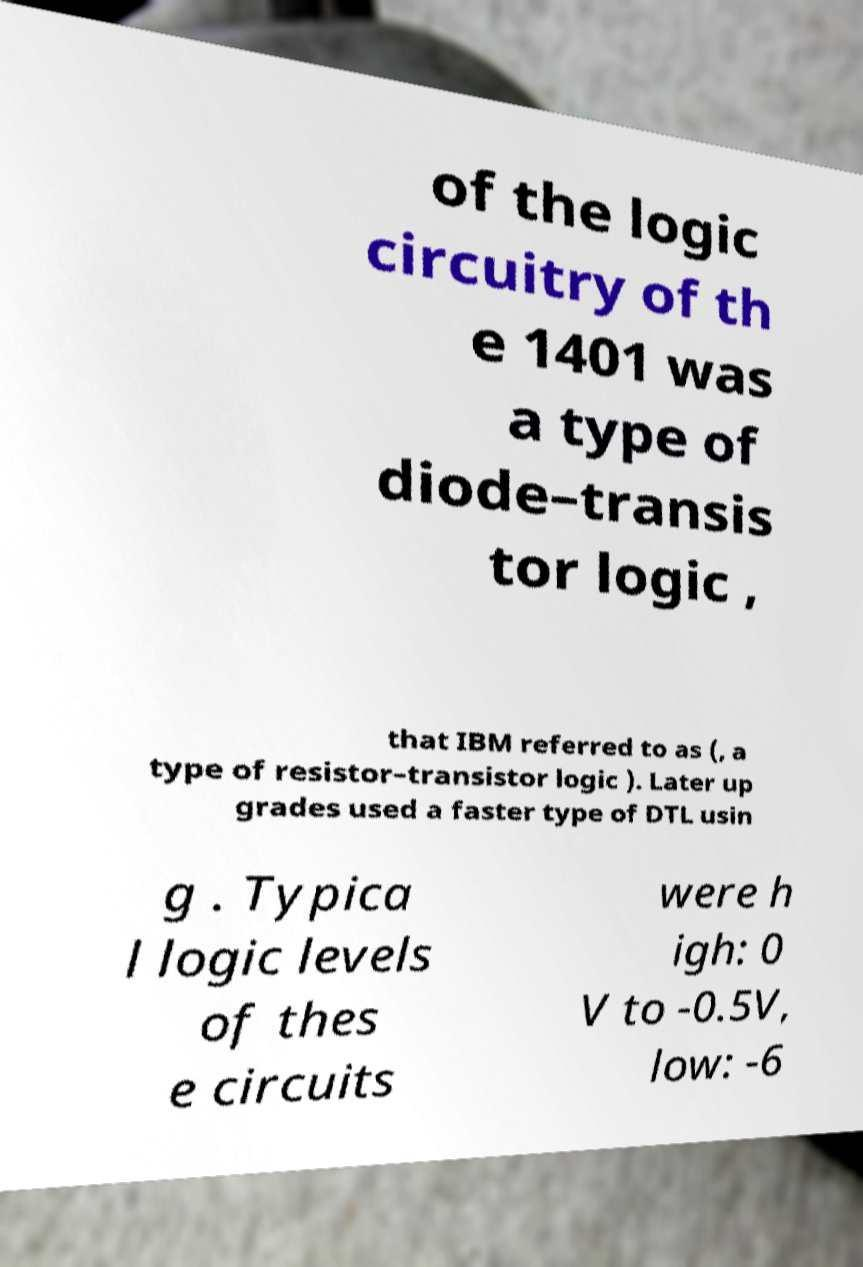Could you extract and type out the text from this image? of the logic circuitry of th e 1401 was a type of diode–transis tor logic , that IBM referred to as (, a type of resistor–transistor logic ). Later up grades used a faster type of DTL usin g . Typica l logic levels of thes e circuits were h igh: 0 V to -0.5V, low: -6 